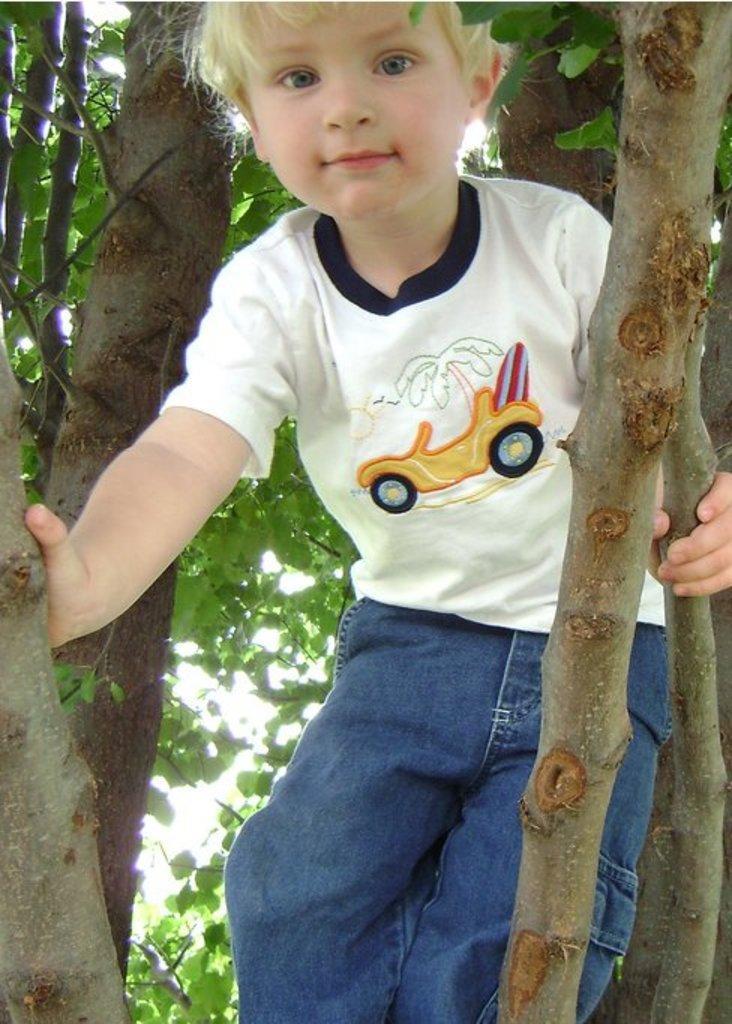How would you summarize this image in a sentence or two? In the center of the image we can see kid on the tree. 